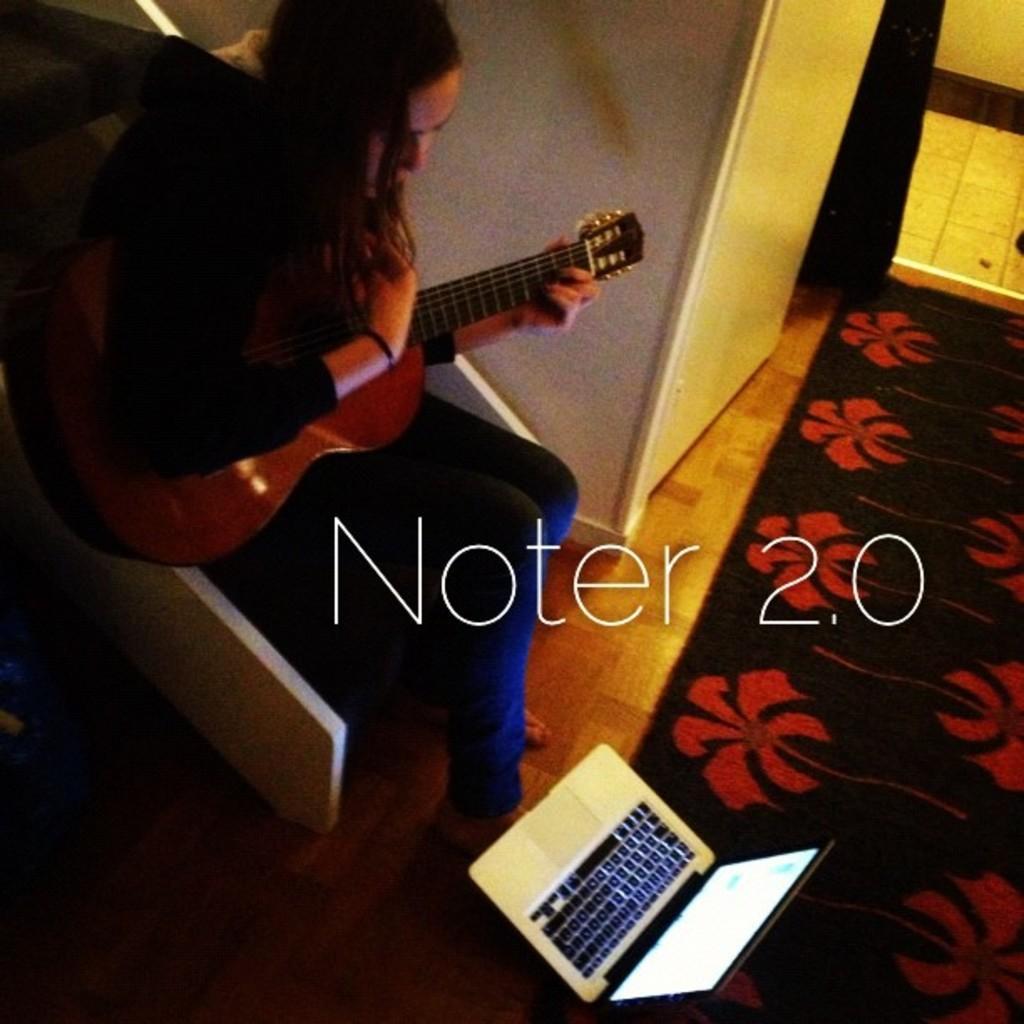Could you give a brief overview of what you see in this image? In this image we can see a woman sitting on a chair. She is having a guitar in her hand and she is looking at this laptop which is on the floor. 